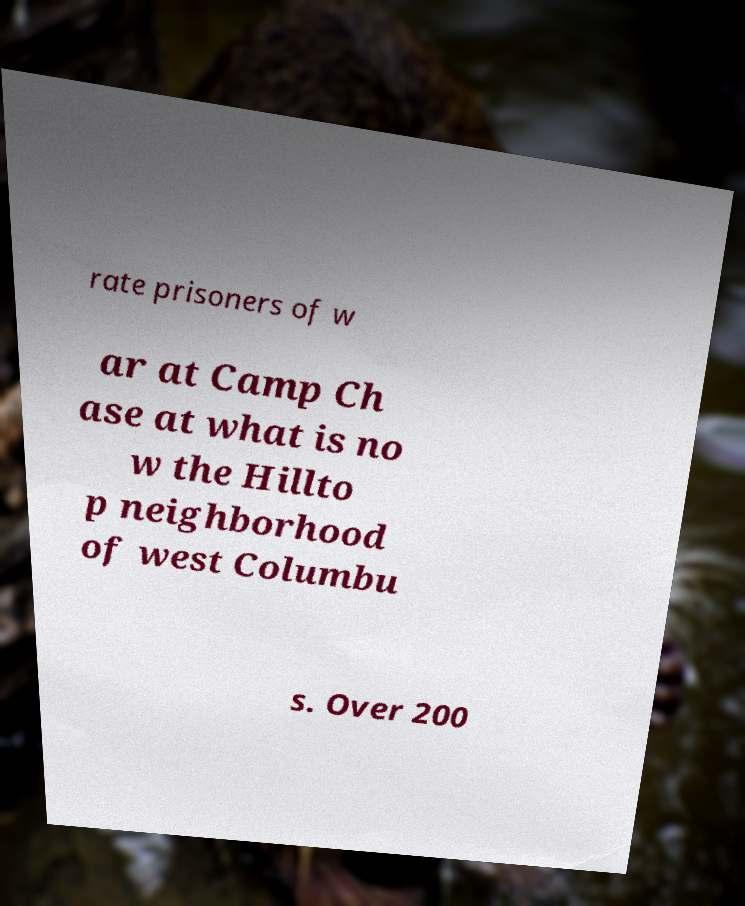Can you read and provide the text displayed in the image?This photo seems to have some interesting text. Can you extract and type it out for me? rate prisoners of w ar at Camp Ch ase at what is no w the Hillto p neighborhood of west Columbu s. Over 200 